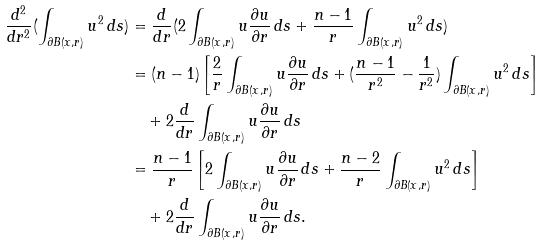<formula> <loc_0><loc_0><loc_500><loc_500>\frac { d ^ { 2 } } { d r ^ { 2 } } ( \int _ { { \partial } B ( x , r ) } u ^ { 2 } \, d s ) & = \frac { d } { d r } ( 2 \int _ { { \partial } B ( x , r ) } u \frac { { \partial } u } { { \partial } r } \, d s + \frac { n - 1 } { r } \int _ { { \partial } B ( x , r ) } u ^ { 2 } \, d s ) \\ & = ( n - 1 ) \left [ \frac { 2 } { r } \int _ { { \partial } B ( x , r ) } u \frac { { \partial } u } { { \partial } r } \, d s + ( \frac { n - 1 } { r ^ { 2 } } - \frac { 1 } { r ^ { 2 } } ) \int _ { { \partial } B ( x , r ) } u ^ { 2 } \, d s \right ] \\ & \quad + 2 \frac { d } { d r } \int _ { { \partial } B ( x , r ) } u \frac { { \partial } u } { { \partial } r } \, d s \\ & = \frac { n - 1 } { r } \left [ 2 \int _ { { \partial } B ( x , r ) } u \frac { { \partial } u } { { \partial } r } \, d s + \frac { n - 2 } { r } \int _ { { \partial } B ( x , r ) } u ^ { 2 } \, d s \right ] \\ & \quad + 2 \frac { d } { d r } \int _ { { \partial } B ( x , r ) } u \frac { { \partial } u } { { \partial } r } \, d s .</formula> 